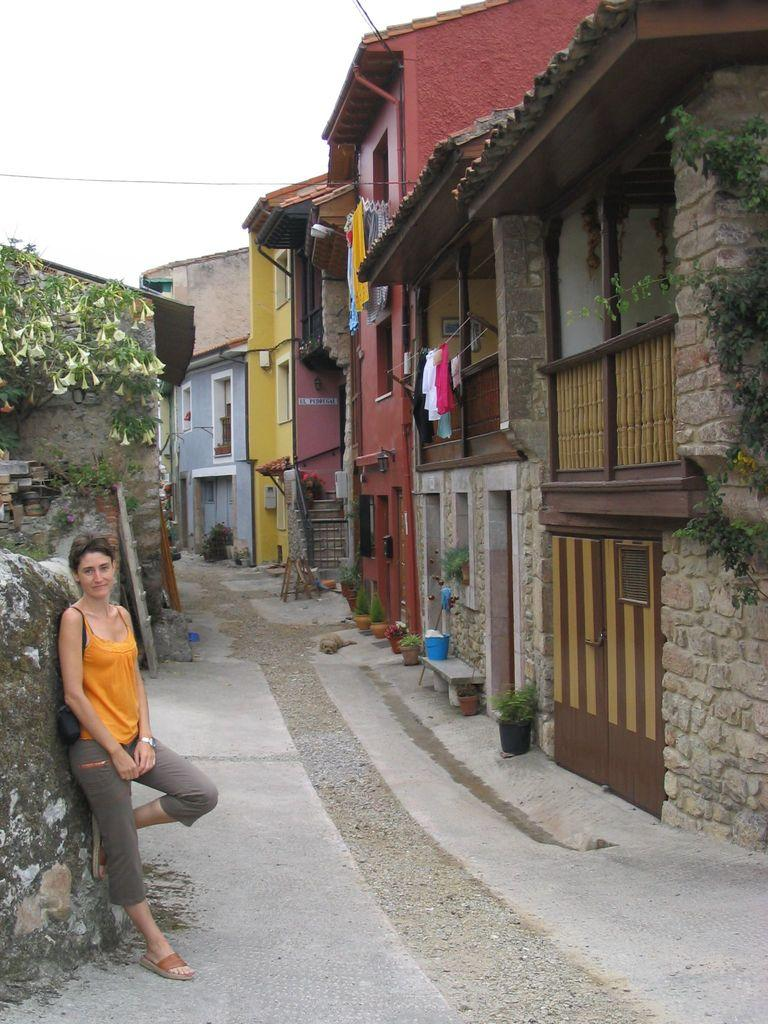What type of structures can be seen in the image? There are buildings in the image. What else is present in the image besides buildings? There are plants and clothes hanging on ropes in the image. Can you describe the woman standing in the image? There is a woman standing in the image. What is the condition of the sky in the image? The sky is cloudy in the image. What organization is responsible for the aftermath of the event depicted in the image? There is no event depicted in the image, and therefore no aftermath or organization involved. How many passengers are visible in the image? There are no passengers present in the image; only a woman, buildings, plants, and clothes hanging on ropes can be seen. 